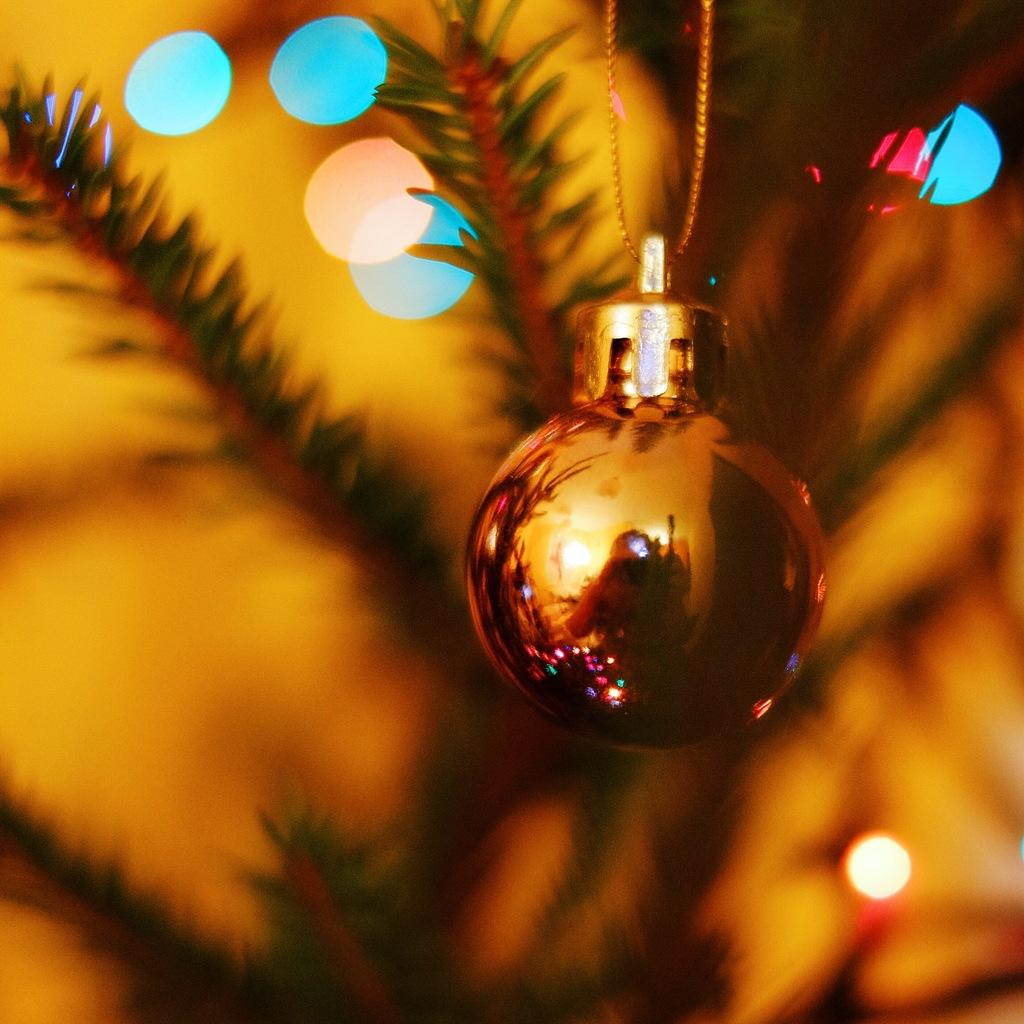What object is the main focus of the image? There is a bauble in the image. What can be seen inside the bauble? The bauble has a reflection of a person. How would you describe the background of the image? The background of the image is blurry. What type of vegetation is visible in the background? Leaves are visible in the background of the image. How many sisters are wearing hats in the image? There are no sisters or hats present in the image; it features a bauble with a reflection of a person and a blurry background with leaves. 